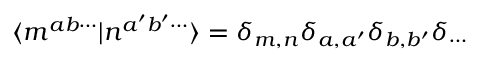<formula> <loc_0><loc_0><loc_500><loc_500>\langle m ^ { a b \cdots } | n ^ { a ^ { \prime } b ^ { \prime } \cdots } \rangle = \delta _ { m , n } \delta _ { a , a ^ { \prime } } \delta _ { b , b ^ { \prime } } \delta _ { \cdots }</formula> 